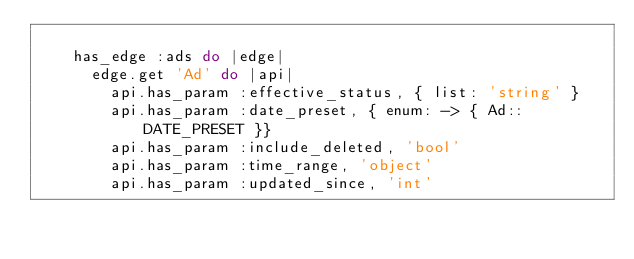Convert code to text. <code><loc_0><loc_0><loc_500><loc_500><_Ruby_>
    has_edge :ads do |edge|
      edge.get 'Ad' do |api|
        api.has_param :effective_status, { list: 'string' }
        api.has_param :date_preset, { enum: -> { Ad::DATE_PRESET }}
        api.has_param :include_deleted, 'bool'
        api.has_param :time_range, 'object'
        api.has_param :updated_since, 'int'</code> 